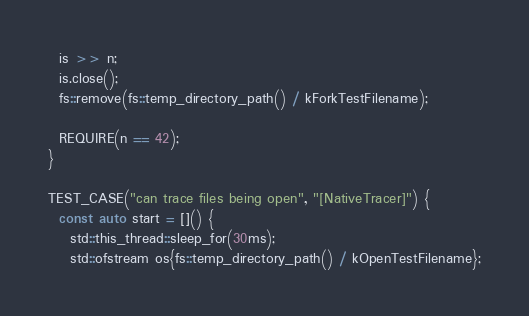Convert code to text. <code><loc_0><loc_0><loc_500><loc_500><_C++_>  is >> n;
  is.close();
  fs::remove(fs::temp_directory_path() / kForkTestFilename);

  REQUIRE(n == 42);
}

TEST_CASE("can trace files being open", "[NativeTracer]") {
  const auto start = []() {
    std::this_thread::sleep_for(30ms);
    std::ofstream os{fs::temp_directory_path() / kOpenTestFilename};</code> 